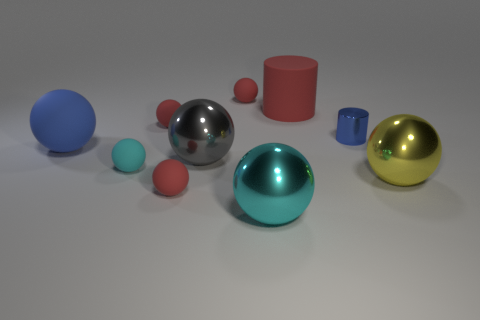Subtract all tiny cyan rubber spheres. How many spheres are left? 7 Subtract all blue cylinders. How many cylinders are left? 1 Subtract 2 cylinders. How many cylinders are left? 0 Add 5 green rubber spheres. How many green rubber spheres exist? 5 Subtract 0 red cubes. How many objects are left? 10 Subtract all balls. How many objects are left? 2 Subtract all purple cylinders. Subtract all purple balls. How many cylinders are left? 2 Subtract all purple cylinders. How many brown balls are left? 0 Subtract all cyan cubes. Subtract all large gray things. How many objects are left? 9 Add 8 large yellow spheres. How many large yellow spheres are left? 9 